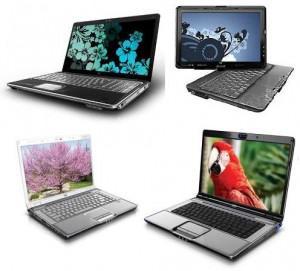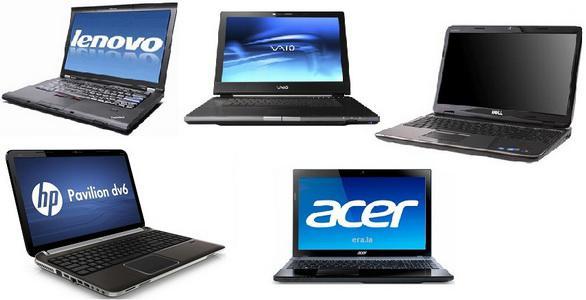The first image is the image on the left, the second image is the image on the right. Evaluate the accuracy of this statement regarding the images: "There is an image of a bird on the screen of one of the computers in the image on the left.". Is it true? Answer yes or no. Yes. 